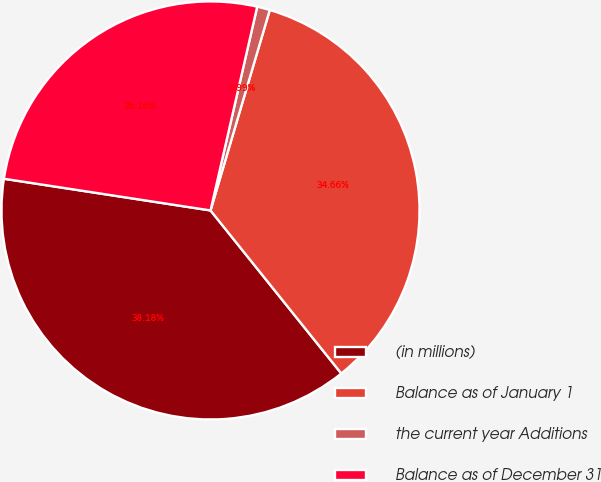Convert chart. <chart><loc_0><loc_0><loc_500><loc_500><pie_chart><fcel>(in millions)<fcel>Balance as of January 1<fcel>the current year Additions<fcel>Balance as of December 31<nl><fcel>38.18%<fcel>34.66%<fcel>0.99%<fcel>26.16%<nl></chart> 